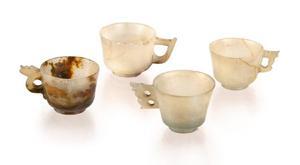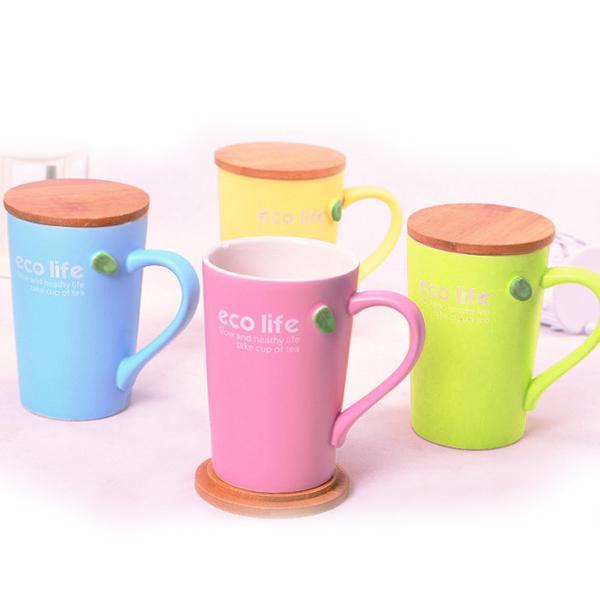The first image is the image on the left, the second image is the image on the right. Examine the images to the left and right. Is the description "There are more cups in the left image than in the right image." accurate? Answer yes or no. No. The first image is the image on the left, the second image is the image on the right. For the images displayed, is the sentence "Some of the cups are stacked one on top of another" factually correct? Answer yes or no. No. 